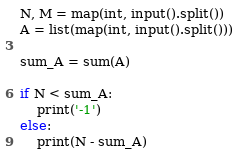<code> <loc_0><loc_0><loc_500><loc_500><_Python_>N, M = map(int, input().split())
A = list(map(int, input().split()))

sum_A = sum(A)

if N < sum_A:
    print('-1')
else:
    print(N - sum_A)
</code> 